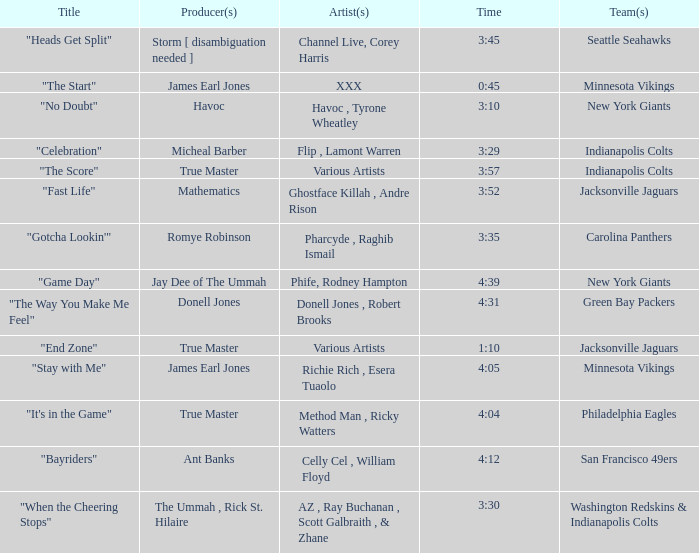How long is the XXX track used by the Minnesota Vikings? 0:45. 